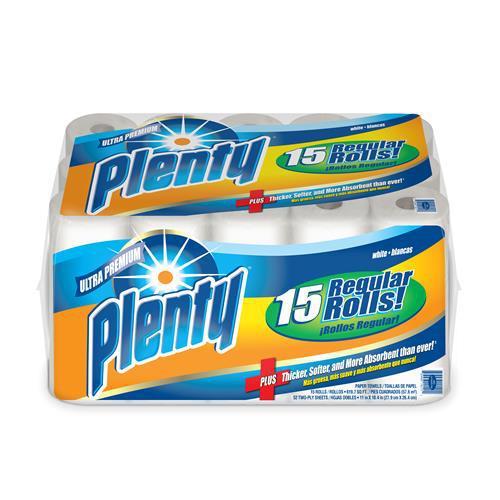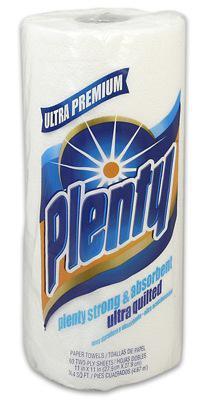The first image is the image on the left, the second image is the image on the right. Considering the images on both sides, is "One picture shows one pack of paper towels, while the other shows only a single roll of paper towels." valid? Answer yes or no. Yes. The first image is the image on the left, the second image is the image on the right. Examine the images to the left and right. Is the description "The lefthand image contains one wrapped multi-roll of towels, and the right image shows one upright roll." accurate? Answer yes or no. Yes. 